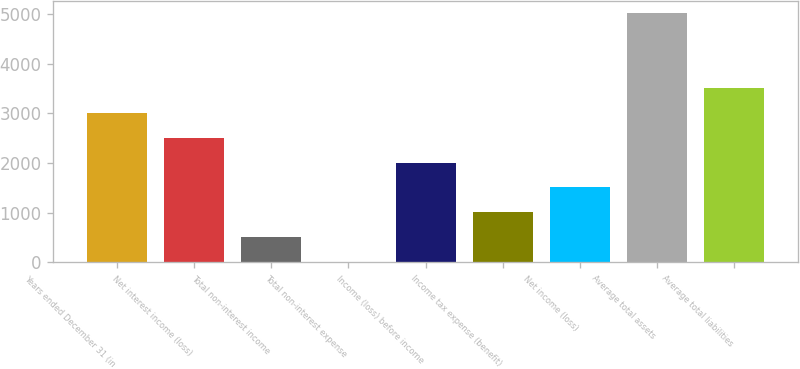Convert chart to OTSL. <chart><loc_0><loc_0><loc_500><loc_500><bar_chart><fcel>Years ended December 31 (in<fcel>Net interest income (loss)<fcel>Total non-interest income<fcel>Total non-interest expense<fcel>Income (loss) before income<fcel>Income tax expense (benefit)<fcel>Net income (loss)<fcel>Average total assets<fcel>Average total liabilities<nl><fcel>3013.22<fcel>2511.25<fcel>503.37<fcel>1.4<fcel>2009.28<fcel>1005.34<fcel>1507.31<fcel>5021.1<fcel>3515.19<nl></chart> 